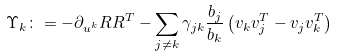<formula> <loc_0><loc_0><loc_500><loc_500>\Upsilon _ { k } \colon = - \partial _ { u ^ { k } } R R ^ { T } - \sum _ { j \neq k } \gamma _ { j k } \frac { b _ { j } } { b _ { k } } \left ( v _ { k } v _ { j } ^ { T } - v _ { j } v _ { k } ^ { T } \right )</formula> 